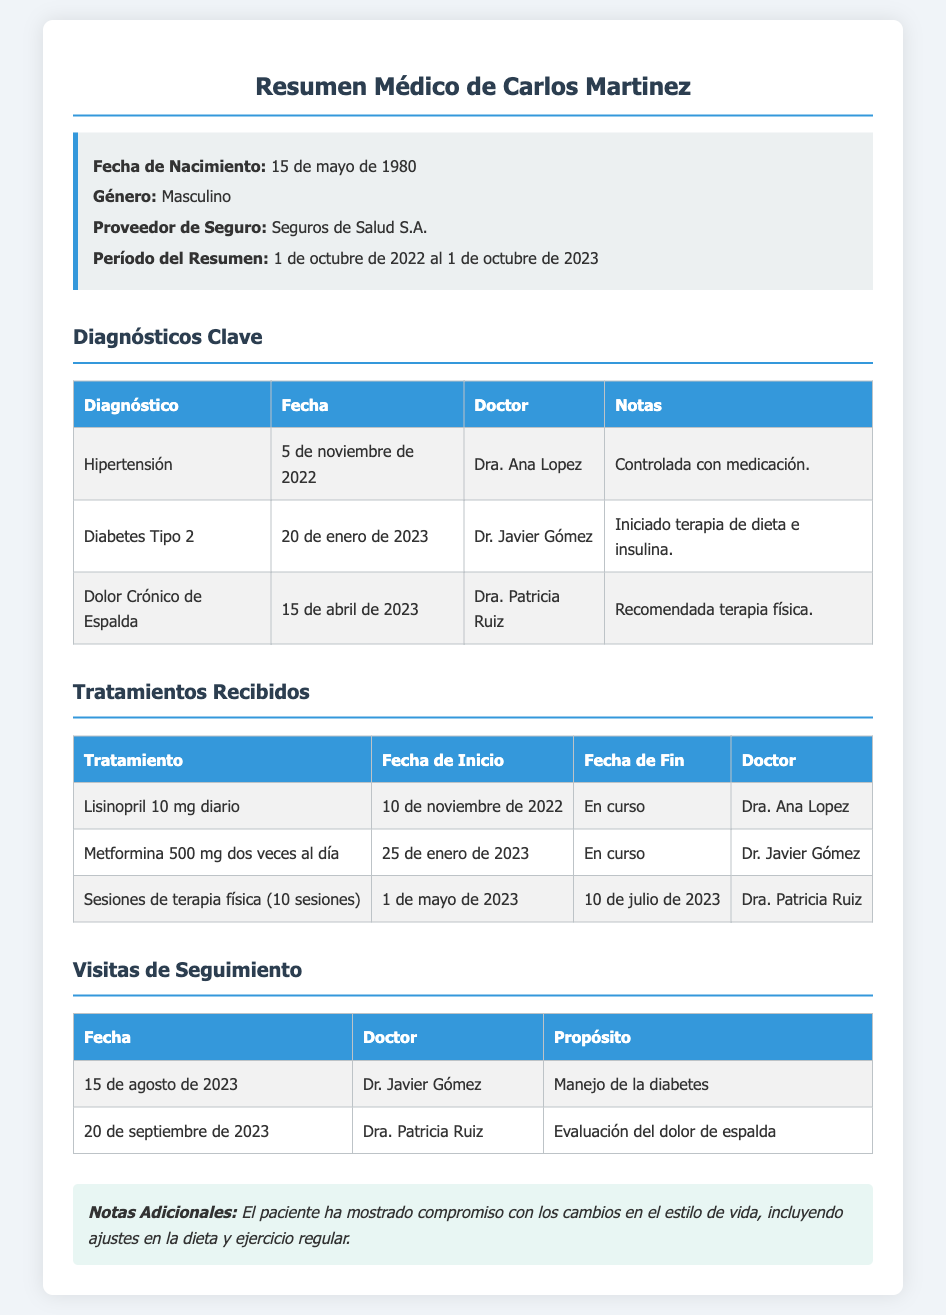¿Cuál es la fecha de nacimiento de Carlos Martinez? La fecha de nacimiento se menciona en el resumen médico, que es el 15 de mayo de 1980.
Answer: 15 de mayo de 1980 ¿Qué diagnóstico recibió Carlos en noviembre de 2022? Según el documento, Carlos fue diagnosticado con hipertensión el 5 de noviembre de 2022.
Answer: Hipertensión ¿Quién es el doctor que indicó la terapia física? En el resumen, se menciona que la doctora Patricia Ruiz recomendó la terapia física para el dolor crónico de espalda.
Answer: Dra. Patricia Ruiz ¿Cuál fue el tratamiento recetado para la diabetes? El tratamiento indicado fue Metformina 500 mg dos veces al día, según el resumen médico.
Answer: Metformina 500 mg dos veces al día ¿Cuántas sesiones de terapia física recibió Carlos? El documento indica que Carlos recibió 10 sesiones de terapia física.
Answer: 10 sesiones ¿Cuándo fue la última visita de seguimiento? La última visita mencionada fue el 20 de septiembre de 2023 para la evaluación del dolor de espalda.
Answer: 20 de septiembre de 2023 ¿Qué observaciones generales se hicieron sobre el compromiso del paciente? En las notas adicionales se menciona que el paciente ha mostrado compromiso con cambios en el estilo de vida.
Answer: Compromiso con cambios en el estilo de vida ¿Cuál es el propósito de la visita con Dr. Javier Gómez? El propósito de la visita fue el manejo de la diabetes, según el documento.
Answer: Manejo de la diabetes 